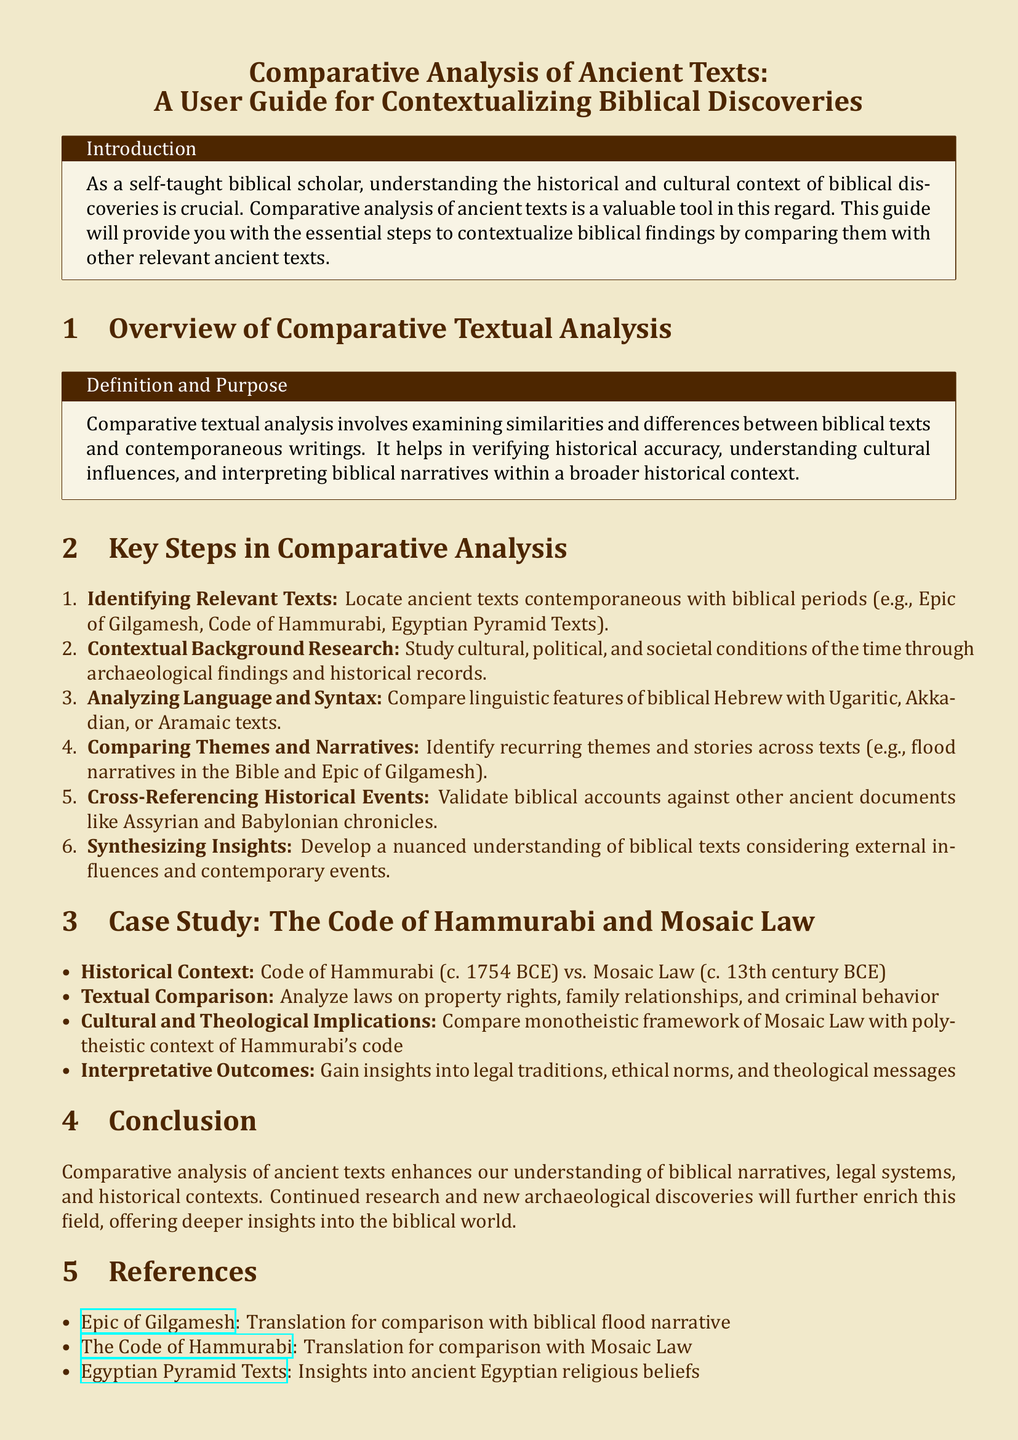What is the title of the document? The title of the document is explicitly mentioned at the beginning of the document as the main heading.
Answer: Comparative Analysis of Ancient Texts: A User Guide for Contextualizing Biblical Discoveries What is the first key step in comparative analysis? The first key step is listed in the enumerated list under key steps for comparative analysis, which is about identifying relevant texts.
Answer: Identifying Relevant Texts What year is the Code of Hammurabi dated to? The specific date for the Code of Hammurabi is provided in the case study section comparing it to the Mosaic Law.
Answer: c. 1754 BCE What ancient text is compared with the biblical flood narrative? The document mentions this comparison within the context of comparative analysis.
Answer: Epic of Gilgamesh What is the primary focus of the user guide? The user guide explicitly states its purpose in the introduction section.
Answer: Contextualizing biblical discoveries What are the cultural implications noted in the case study? The document outlines specific cultural implications when examining the laws.
Answer: Polytheistic context vs. Monotheistic framework How many steps are described in the comparative analysis section? The document enumerates the steps in the comparative analysis section of the user guide.
Answer: Six steps What type of analysis does this guide emphasize? The document clearly defines the type of analysis it supports in the overview section.
Answer: Comparative textual analysis What type of insights does comparative analysis provide? The conclusion summarizes the outcomes of undertaking a comparative analysis as noted in the ending section.
Answer: Understanding biblical narratives, legal systems, and historical contexts 